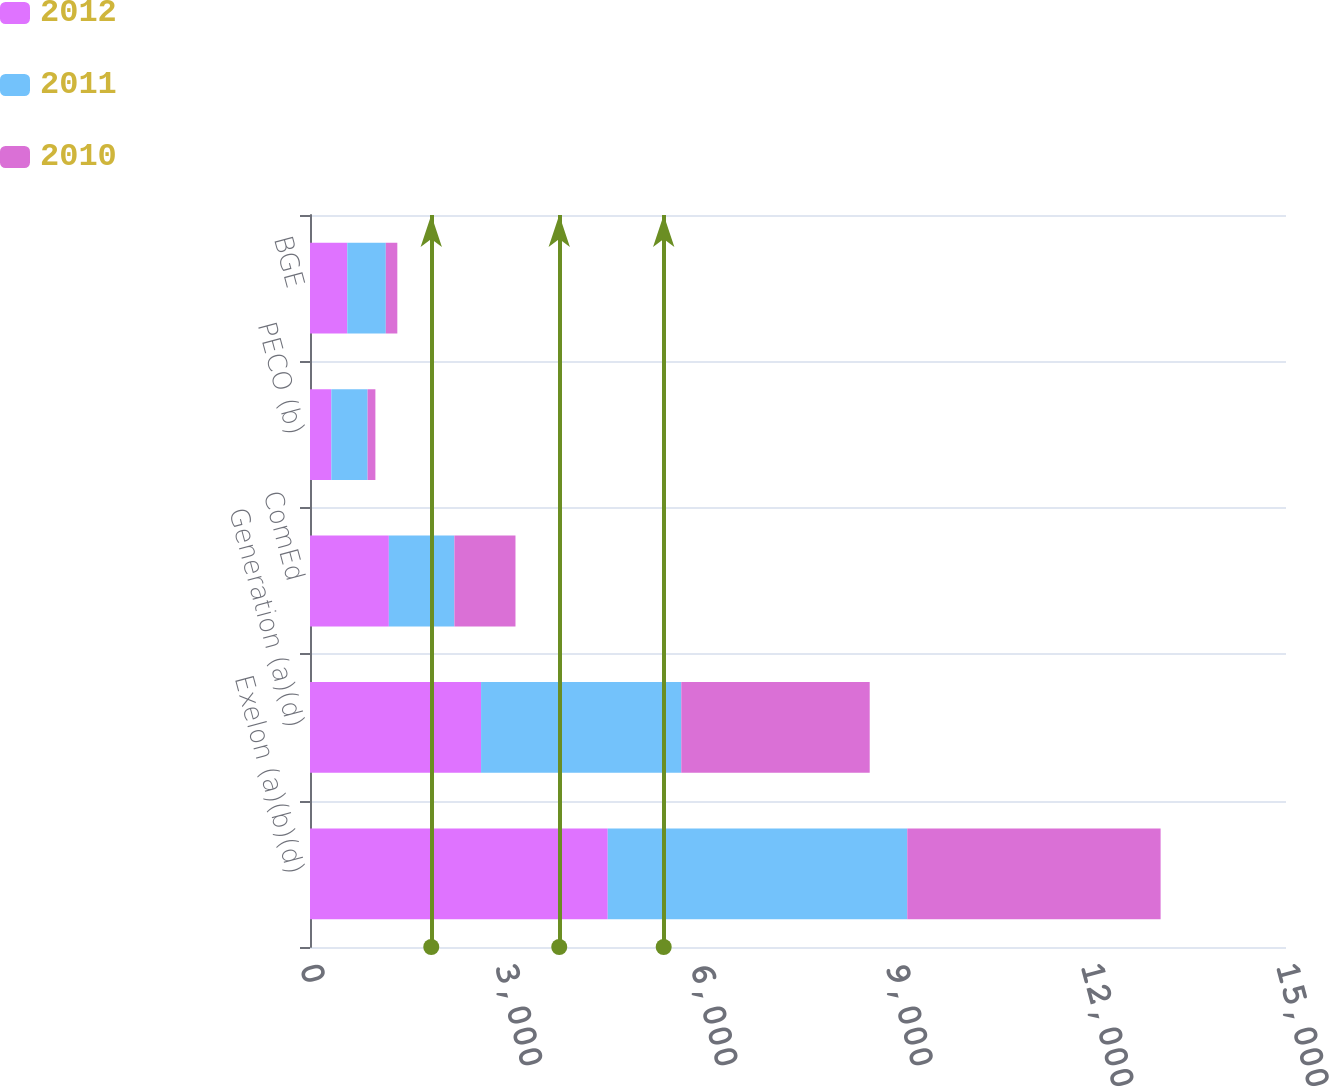<chart> <loc_0><loc_0><loc_500><loc_500><stacked_bar_chart><ecel><fcel>Exelon (a)(b)(d)<fcel>Generation (a)(d)<fcel>ComEd<fcel>PECO (b)<fcel>BGE<nl><fcel>2012<fcel>4576<fcel>2629<fcel>1212<fcel>328<fcel>573<nl><fcel>2011<fcel>4603<fcel>3077<fcel>1007<fcel>557<fcel>592<nl><fcel>2010<fcel>3894<fcel>2896<fcel>939<fcel>120<fcel>177<nl></chart> 